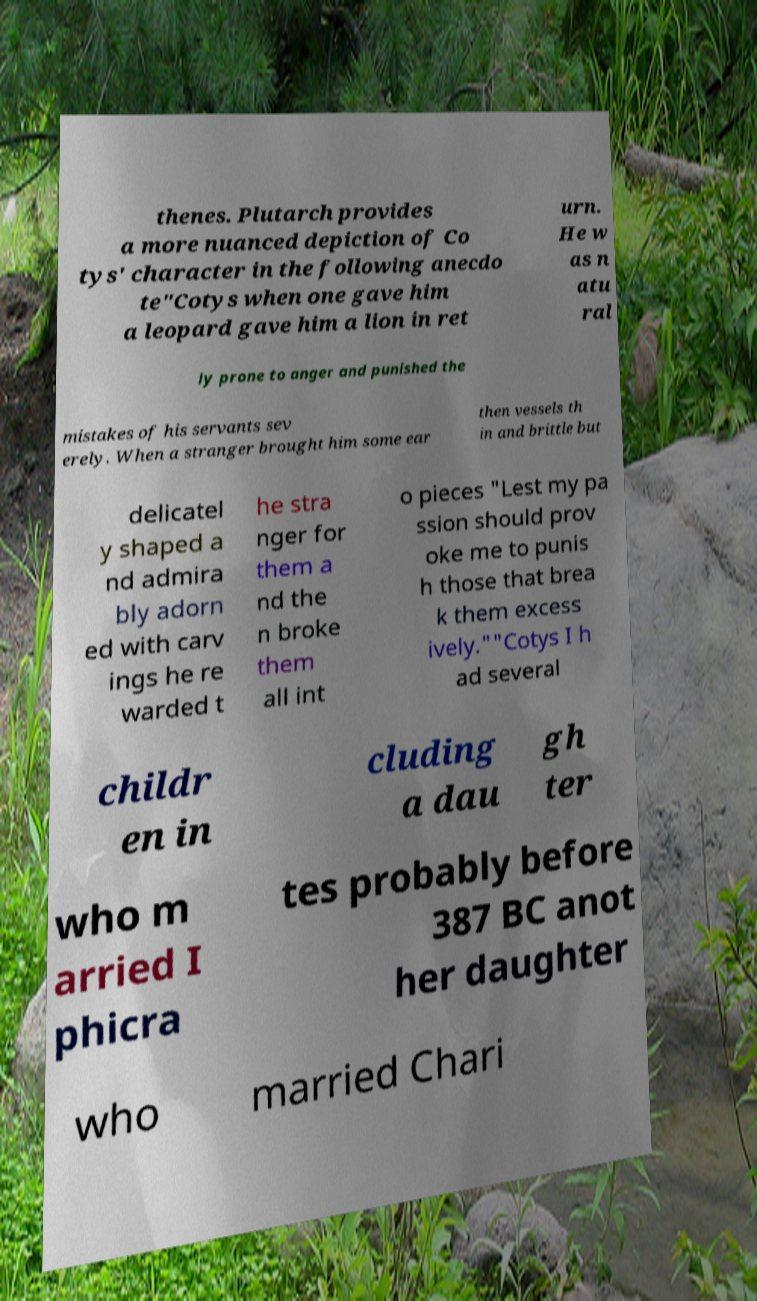I need the written content from this picture converted into text. Can you do that? thenes. Plutarch provides a more nuanced depiction of Co tys' character in the following anecdo te"Cotys when one gave him a leopard gave him a lion in ret urn. He w as n atu ral ly prone to anger and punished the mistakes of his servants sev erely. When a stranger brought him some ear then vessels th in and brittle but delicatel y shaped a nd admira bly adorn ed with carv ings he re warded t he stra nger for them a nd the n broke them all int o pieces "Lest my pa ssion should prov oke me to punis h those that brea k them excess ively.""Cotys I h ad several childr en in cluding a dau gh ter who m arried I phicra tes probably before 387 BC anot her daughter who married Chari 